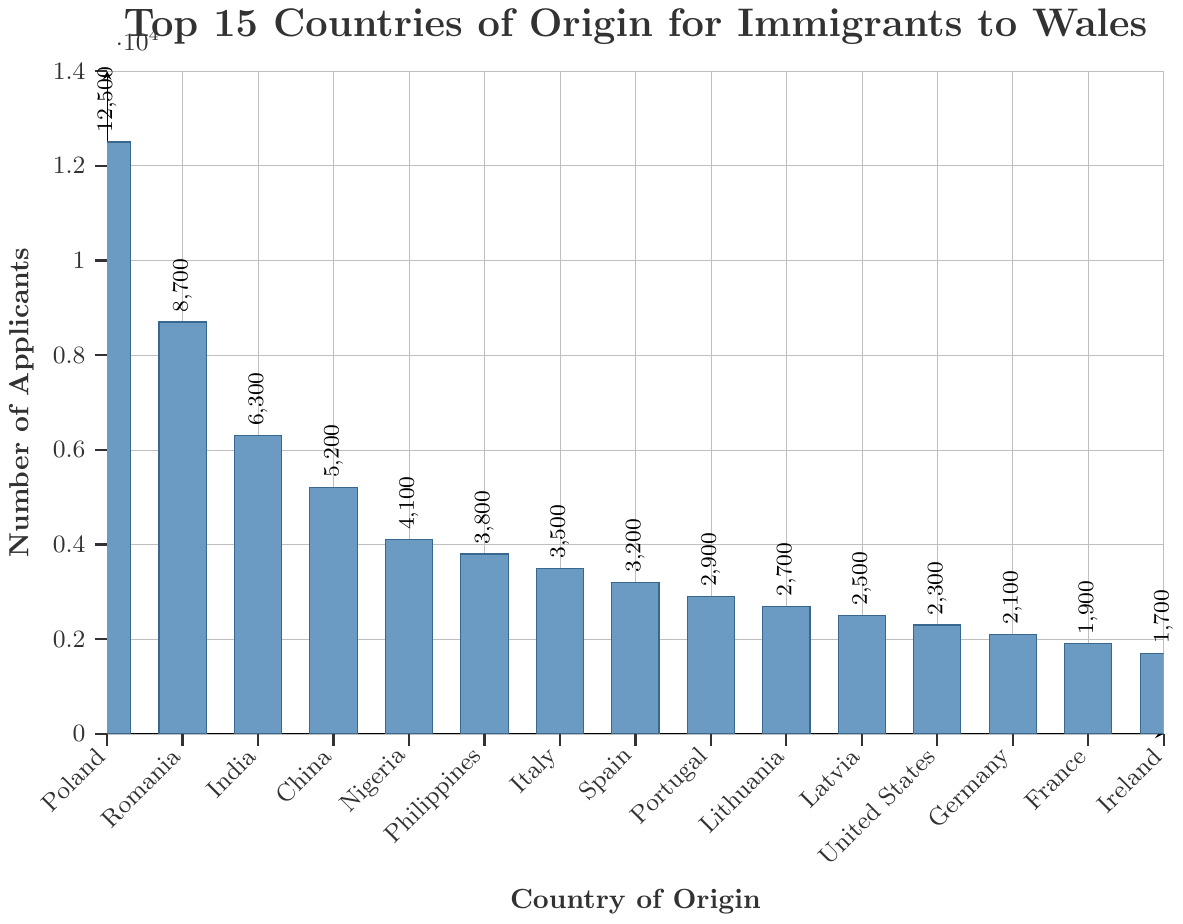Which country has the highest number of applicants? The bar for Poland is the tallest and has the largest value indicated by the number 12500 above it.
Answer: Poland How many more applicants are there from Romania than from Lithuania? The number of applicants from Romania is 8700, and from Lithuania is 2700. The difference is 8700 - 2700 = 6000.
Answer: 6000 Which countries have fewer than 3000 applicants? By looking at the bars that do not reach the 3000 mark on the vertical axis, the countries are Latvia, United States, Germany, France, and Ireland.
Answer: Latvia, United States, Germany, France, and Ireland Which country has the lowest number of applicants, and what is that number? The shortest bar represents Ireland with the number 1700 indicated above it.
Answer: Ireland, 1700 What is the total number of applicants from China and the Philippines combined? The applicants from China are 5200, and from the Philippines are 3800. The total is 5200 + 3800 = 9000.
Answer: 9000 Rank the top three countries by the number of applicants. The three tallest bars represent Poland (12500), Romania (8700), and India (6300).
Answer: Poland, Romania, India Is the number of applicants from Nigeria more, less, or equal to the number from Italy? The bar for Nigeria shows 4100 applicants, while the bar for Italy shows 3500 applicants. 4100 is more than 3500.
Answer: More What is the combined total number of applicants from Spain, Portugal, and Lithuania? The applicants from Spain are 3200, from Portugal are 2900, and from Lithuania are 2700. The combined total is 3200 + 2900 + 2700 = 8800.
Answer: 8800 How many countries have more than 5000 applicants? Count the bars that exceed the 5000 mark: Poland (12500), Romania (8700), and India (6300). There are three countries.
Answer: 3 Compare the number of applicants from the United States and Germany. Which country has more and by what amount? The number of applicants from the United States is 2300, and from Germany is 2100. The difference is 2300 - 2100 = 200. The United States has more applicants.
Answer: United States, 200 